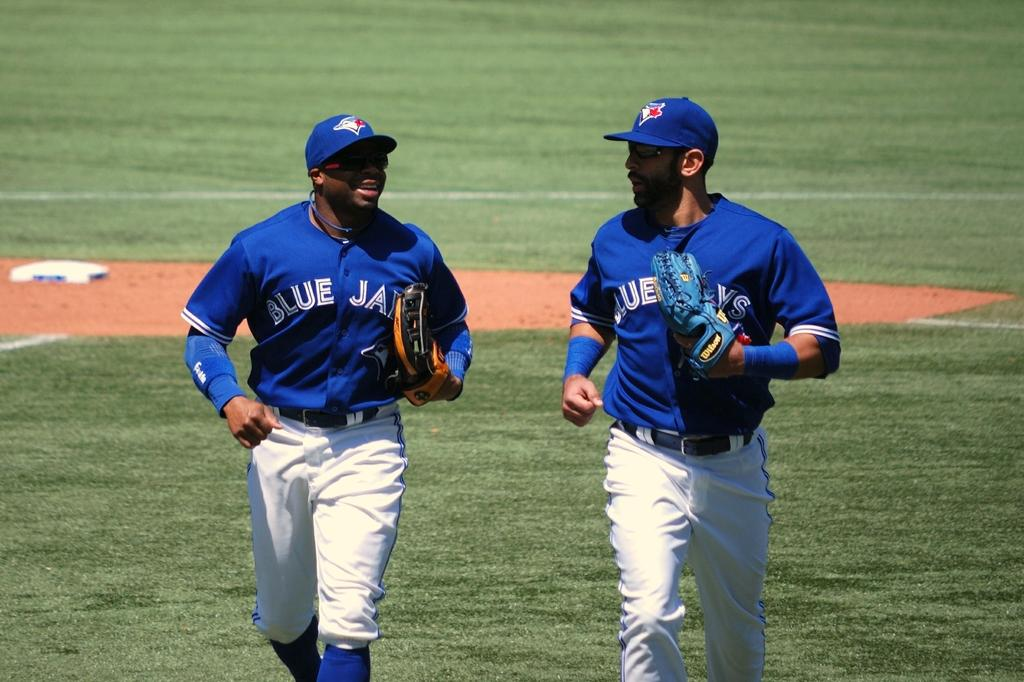<image>
Create a compact narrative representing the image presented. A couple of Blue Jays players running in together 